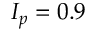Convert formula to latex. <formula><loc_0><loc_0><loc_500><loc_500>I _ { p } = 0 . 9</formula> 